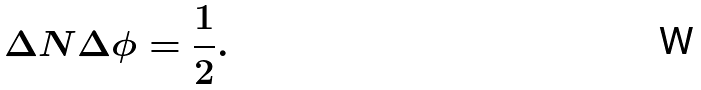<formula> <loc_0><loc_0><loc_500><loc_500>\Delta { N } \Delta { \phi } = \frac { 1 } { 2 } .</formula> 